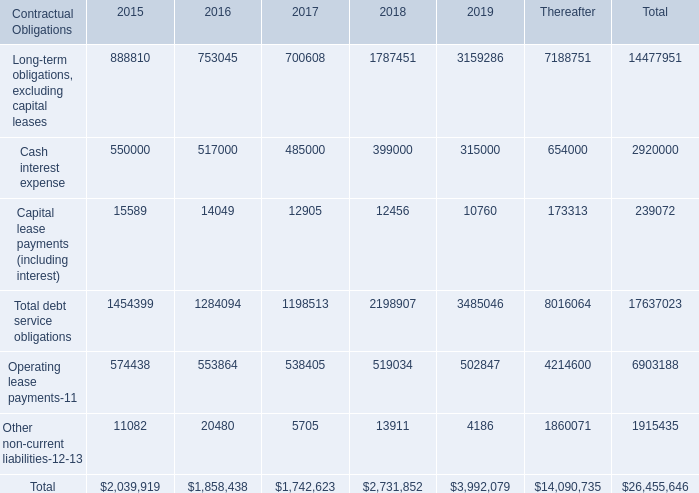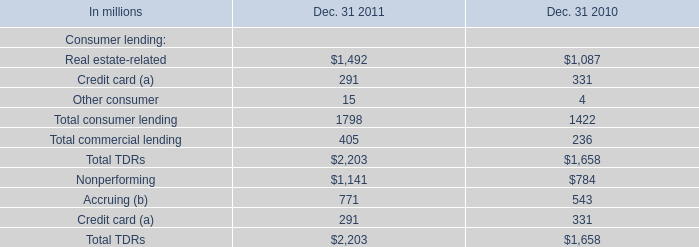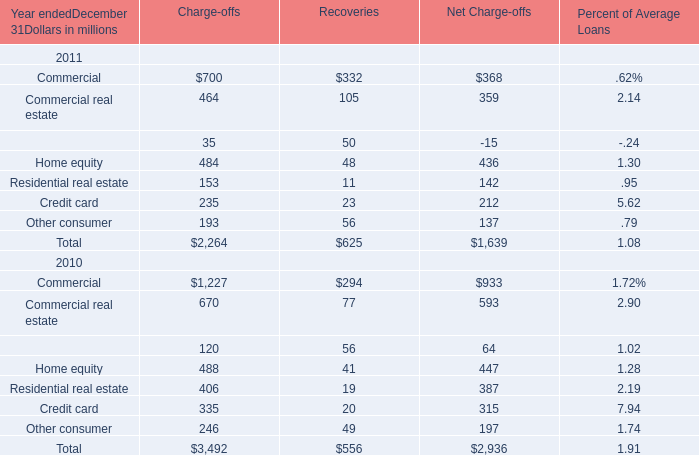Which year is home equity for recoveries the highest? 
Answer: 2011. 